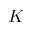<formula> <loc_0><loc_0><loc_500><loc_500>K</formula> 